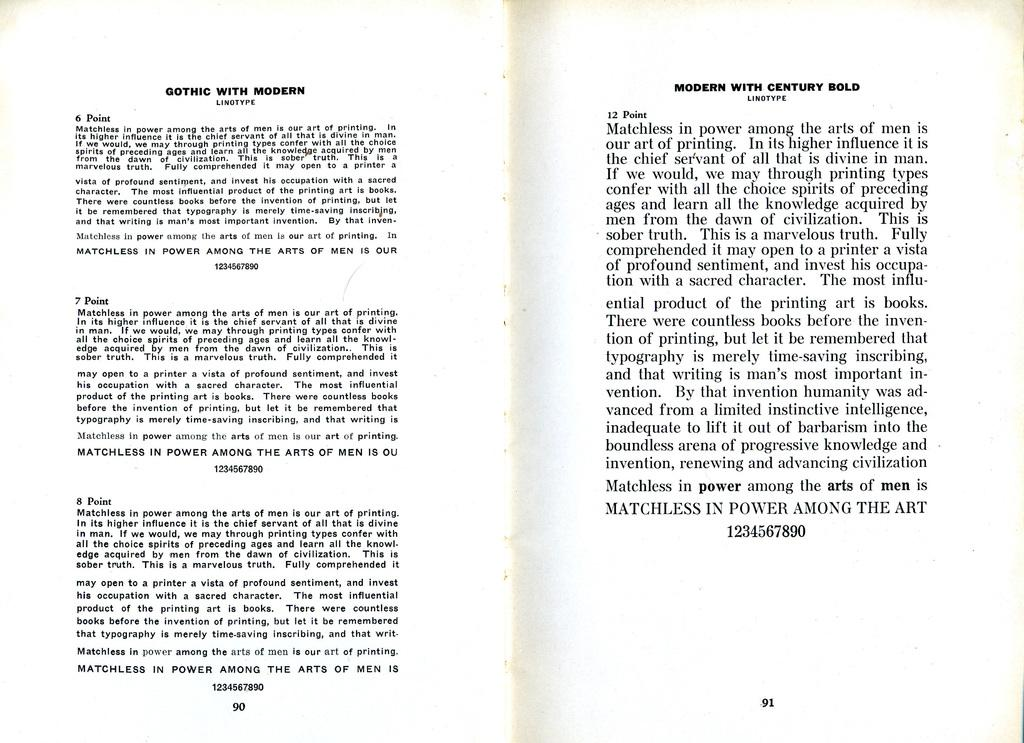Provide a one-sentence caption for the provided image. The book discusses support for Gothic with modern linotype. 